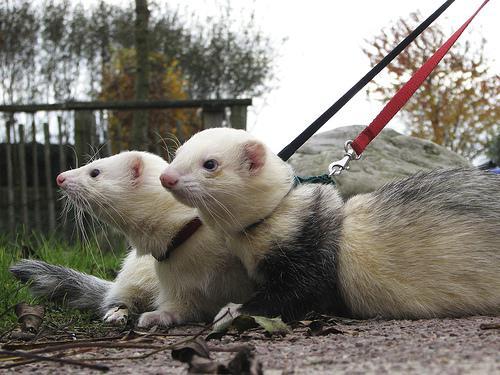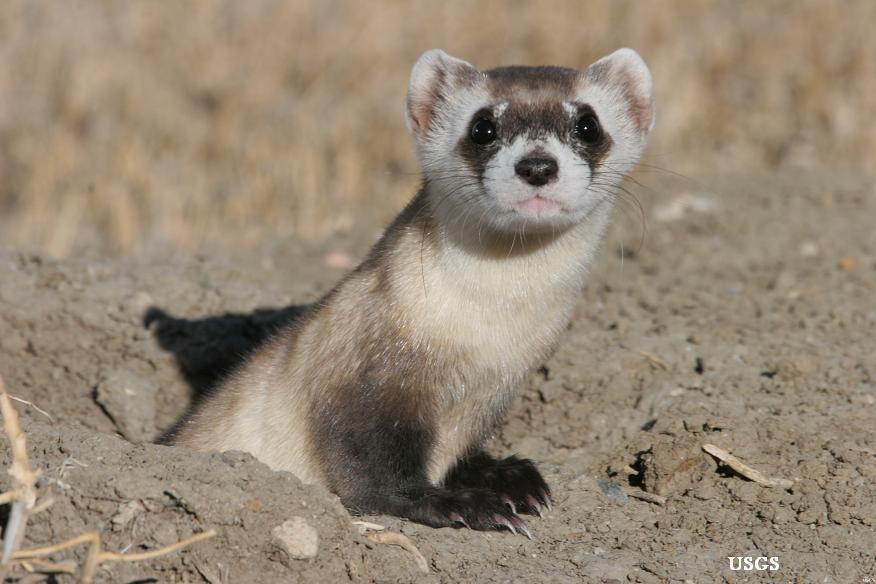The first image is the image on the left, the second image is the image on the right. Considering the images on both sides, is "The right image contains one ferret emerging from a hole in the dirt." valid? Answer yes or no. Yes. 